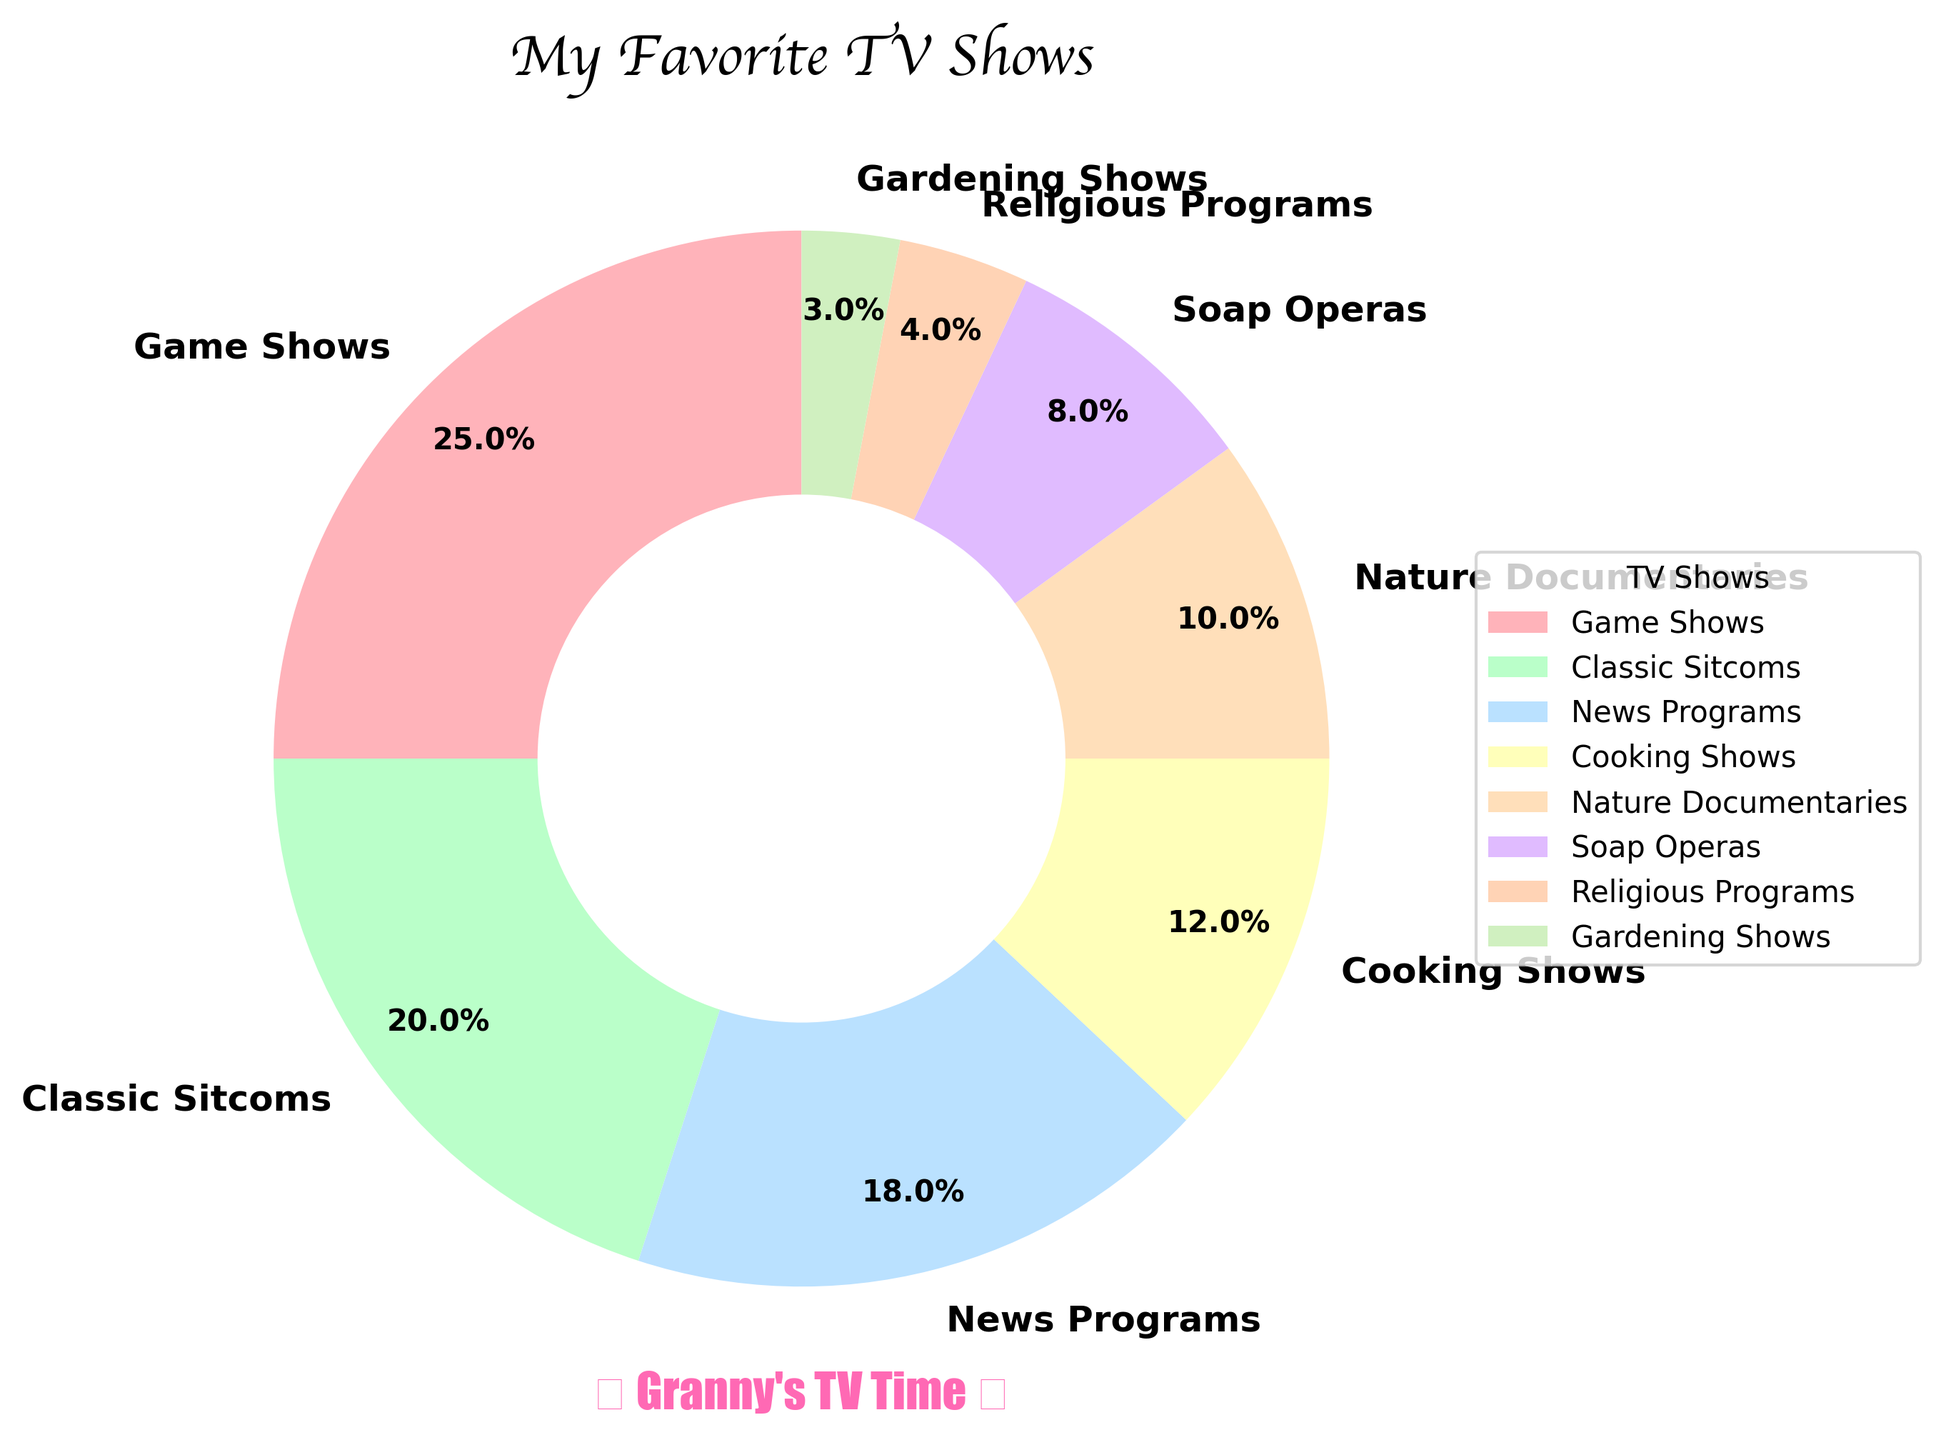What percentage of seniors prefer watching Game Shows? By looking at the segment labeled "Game Shows" in the pie chart, the percentage is directly shown inside the segment.
Answer: 25% Which two genres combined account for more than one-third of the preferences? Adding the percentages of different genres, we see that "Game Shows" (25%) and "Classic Sitcoms" (20%) together account for 45%, which is more than one-third (33.33%) of the total.
Answer: Game Shows and Classic Sitcoms Which genre is preferred by the least percentage of seniors? The segment with the smallest percentage label represents the least preferred genre. According to the pie chart, "Gardening Shows" has the smallest percentage at 3%.
Answer: Gardening Shows How many more seniors prefer Game Shows over News Programs? Compare the percentage for Game Shows (25%) and News Programs (18%) by subtracting the smaller from the larger. Calculation: 25% - 18% = 7%.
Answer: 7% Do Cooking Shows have a higher preference than Classic Sitcoms? Compare the percentages of Cooking Shows (12%) and Classic Sitcoms (20%). Since 12% is less than 20%, Cooking Shows have a lower preference than Classic Sitcoms.
Answer: No What is the combined percentage for genres related to information and knowledge (News Programs and Nature Documentaries)? Add the percentages of News Programs (18%) and Nature Documentaries (10%). Calculation: 18% + 10% = 28%.
Answer: 28% If you combine the percentages for Soap Operas, Religious Programs, and Gardening Shows, is it more or less than 20%? Add the percentages for Soap Operas (8%), Religious Programs (4%), and Gardening Shows (3%). Calculation: 8% + 4% + 3% = 15%, which is less than 20%.
Answer: Less What color represents "Classic Sitcoms" on the pie chart? Look for the label "Classic Sitcoms" and identify its corresponding color segment. According to the pie chart, it is represented by a green segment.
Answer: Green Which genre is less popular: Nature Documentaries or Soap Operas? Compare the percentages of Nature Documentaries (10%) and Soap Operas (8%), and see which is lower. Soap Operas have a lower percentage than Nature Documentaries.
Answer: Soap Operas What is the total percentage of genres associated with relaxation or leisure (Game Shows, Classic Sitcoms, and Gardening Shows)? Add the percentages of Game Shows (25%), Classic Sitcoms (20%), and Gardening Shows (3%). Calculation: 25% + 20% + 3% = 48%.
Answer: 48% 